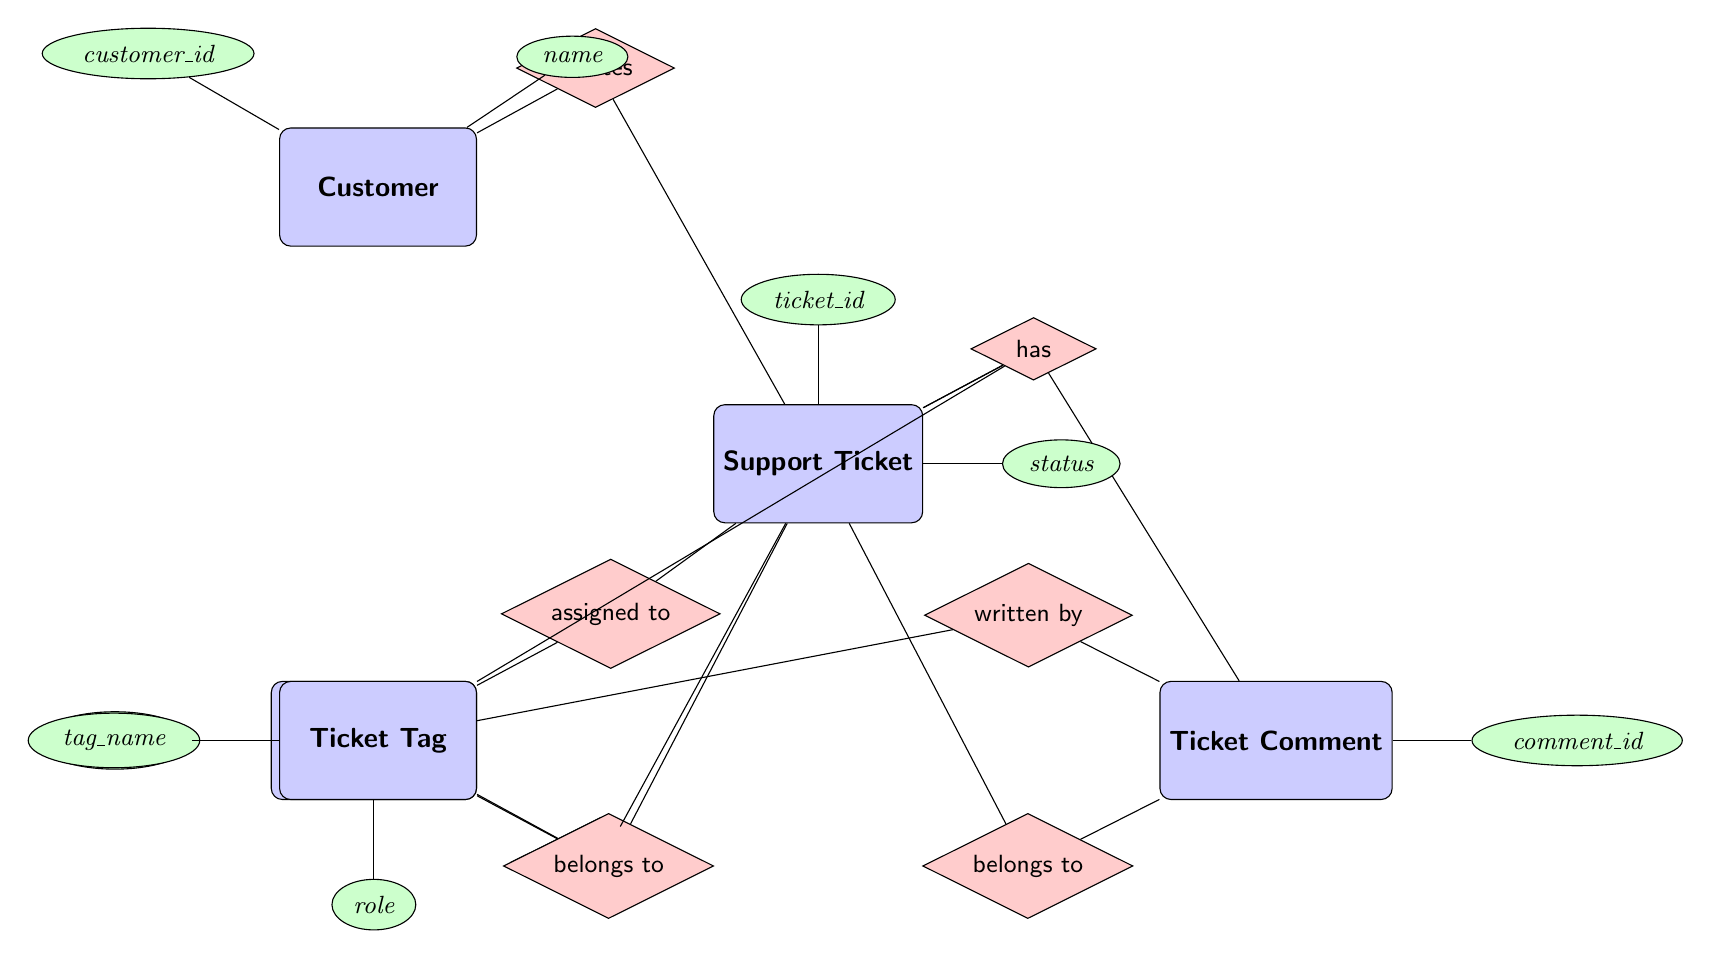What is the primary entity for creating support tickets? The diagram indicates a direct relationship flowing from the "Customer" entity to the "Support Ticket" entity labeled "creates". Thus, "Customer" is the primary entity responsible for creating support tickets.
Answer: Customer How many attributes does the Support Ticket have? By examining the "Support Ticket" entity, there are six listed attributes: ticket_id, subject, description, status, created_date, and updated_date. Therefore, the total count of attributes is six.
Answer: 6 Which entity manages the Support Ticket? The relationship labeled "manages" connects the "Support Agent" to the "Support Ticket". This clearly signifies that "Support Agent" is responsible for managing support tickets.
Answer: Support Agent How many relationships does the Ticket Comment have with other entities? The "Ticket Comment" entity connects with the "Support Ticket" via the "belongs to" relationship and with the "Support Agent" via the "written by" relationship. Therefore, it establishes two relationships.
Answer: 2 What does the Ticket Tag belong to? The diagram shows that the "Ticket Tag" is related to the "Support Ticket" through the "belongs to" relationship. Hence, the "Ticket Tag" belongs to the "Support Ticket".
Answer: Support Ticket Which attribute of the Support Agent indicates their role? The attribute related to the role of the Support Agent is explicitly stated as "role". Therefore, "role" is the attribute indicating their role.
Answer: role How do Support Agents interact with Support Tickets? The diagram presents two relationships that involve Support Agents: "assigned to" (assigning tickets) and "manages" (overseeing them). Together, these show that Support Agents can both manage and be assigned support tickets.
Answer: assigned to, manages What type of entity is Ticket Tag? In the diagram, "Ticket Tag" is represented as a rectangle with rounded corners, which indicates that it is classified as an entity. Thus, its type is an entity.
Answer: Entity 